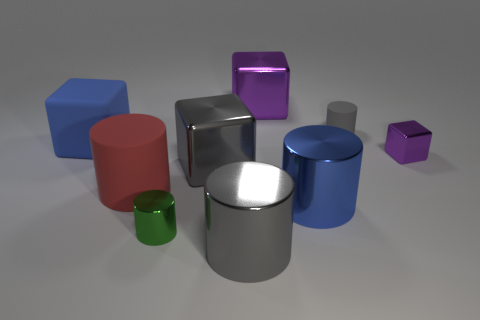The shiny object right of the large blue metallic cylinder has what shape?
Keep it short and to the point. Cube. What number of large blocks are right of the tiny green metal object and in front of the big purple cube?
Your answer should be very brief. 1. There is a matte block; is its size the same as the cylinder that is on the left side of the green thing?
Give a very brief answer. Yes. There is a purple object that is behind the tiny purple block on the right side of the cylinder behind the large red rubber thing; what is its size?
Make the answer very short. Large. There is a matte cylinder on the left side of the small green metal object; how big is it?
Keep it short and to the point. Large. What is the shape of the small gray thing that is made of the same material as the big red cylinder?
Your answer should be very brief. Cylinder. Is the material of the blue object in front of the large red matte object the same as the large red object?
Your answer should be compact. No. How many other things are the same material as the big red cylinder?
Provide a succinct answer. 2. How many objects are either blue objects that are in front of the large blue cube or gray cylinders in front of the big blue matte thing?
Give a very brief answer. 2. Does the metal thing in front of the green thing have the same shape as the tiny object in front of the gray shiny block?
Keep it short and to the point. Yes. 